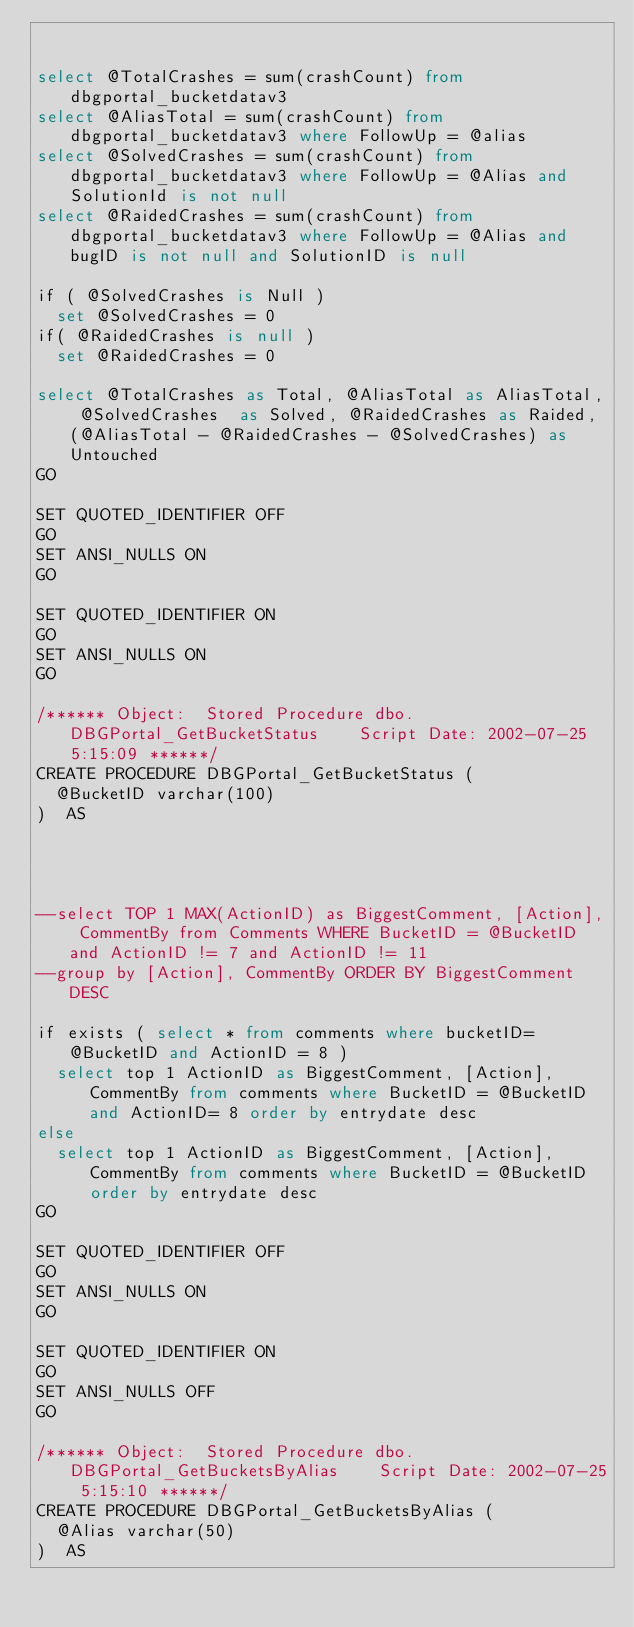<code> <loc_0><loc_0><loc_500><loc_500><_SQL_>

select @TotalCrashes = sum(crashCount) from dbgportal_bucketdatav3 
select @AliasTotal = sum(crashCount) from dbgportal_bucketdatav3 where FollowUp = @alias
select @SolvedCrashes = sum(crashCount) from dbgportal_bucketdatav3 where FollowUp = @Alias and SolutionId is not null 
select @RaidedCrashes = sum(crashCount) from dbgportal_bucketdatav3 where FollowUp = @Alias and bugID is not null and SolutionID is null

if ( @SolvedCrashes is Null )
	set @SolvedCrashes = 0
if( @RaidedCrashes is null )
	set @RaidedCrashes = 0

select @TotalCrashes as Total, @AliasTotal as AliasTotal, @SolvedCrashes  as Solved, @RaidedCrashes as Raided, (@AliasTotal - @RaidedCrashes - @SolvedCrashes) as Untouched
GO

SET QUOTED_IDENTIFIER OFF 
GO
SET ANSI_NULLS ON 
GO

SET QUOTED_IDENTIFIER ON 
GO
SET ANSI_NULLS ON 
GO

/****** Object:  Stored Procedure dbo.DBGPortal_GetBucketStatus    Script Date: 2002-07-25 5:15:09 ******/
CREATE PROCEDURE DBGPortal_GetBucketStatus (
	@BucketID varchar(100)
)  AS




--select TOP 1 MAX(ActionID) as BiggestComment, [Action], CommentBy from Comments WHERE BucketID = @BucketID and ActionID != 7 and ActionID != 11 
--group by [Action], CommentBy ORDER BY BiggestComment DESC

if exists ( select * from comments where bucketID= @BucketID and ActionID = 8 )
	select top 1 ActionID as BiggestComment, [Action],  CommentBy from comments where BucketID = @BucketID and ActionID= 8 order by entrydate desc
else
	select top 1 ActionID as BiggestComment, [Action],  CommentBy from comments where BucketID = @BucketID order by entrydate desc
GO

SET QUOTED_IDENTIFIER OFF 
GO
SET ANSI_NULLS ON 
GO

SET QUOTED_IDENTIFIER ON 
GO
SET ANSI_NULLS OFF 
GO

/****** Object:  Stored Procedure dbo.DBGPortal_GetBucketsByAlias    Script Date: 2002-07-25 5:15:10 ******/
CREATE PROCEDURE DBGPortal_GetBucketsByAlias (
	@Alias varchar(50)
)  AS

</code> 